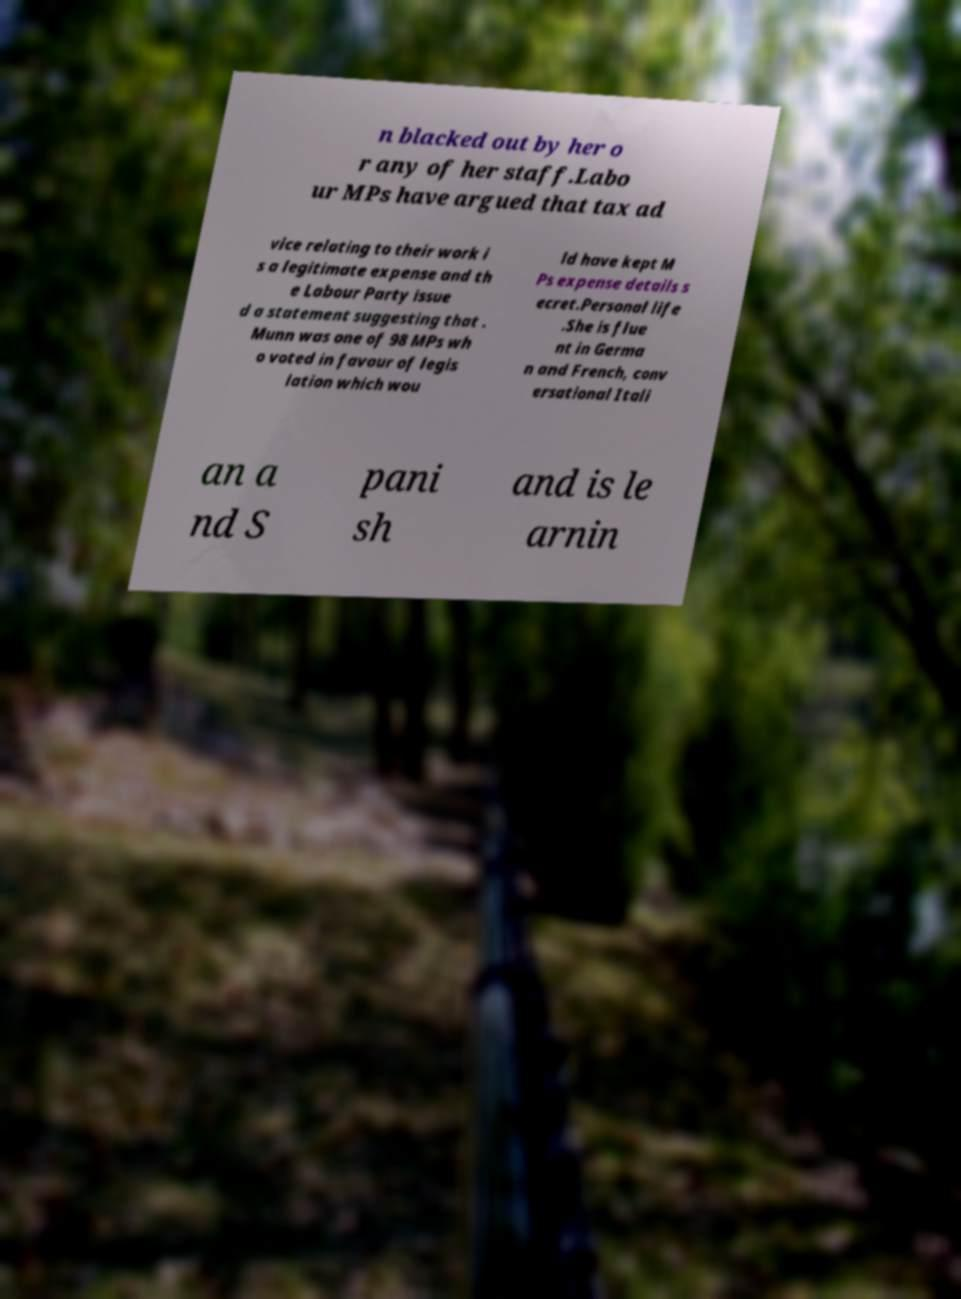Could you extract and type out the text from this image? n blacked out by her o r any of her staff.Labo ur MPs have argued that tax ad vice relating to their work i s a legitimate expense and th e Labour Party issue d a statement suggesting that . Munn was one of 98 MPs wh o voted in favour of legis lation which wou ld have kept M Ps expense details s ecret.Personal life .She is flue nt in Germa n and French, conv ersational Itali an a nd S pani sh and is le arnin 